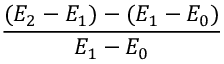Convert formula to latex. <formula><loc_0><loc_0><loc_500><loc_500>\frac { ( E _ { 2 } - E _ { 1 } ) - ( E _ { 1 } - E _ { 0 } ) } { E _ { 1 } - E _ { 0 } }</formula> 